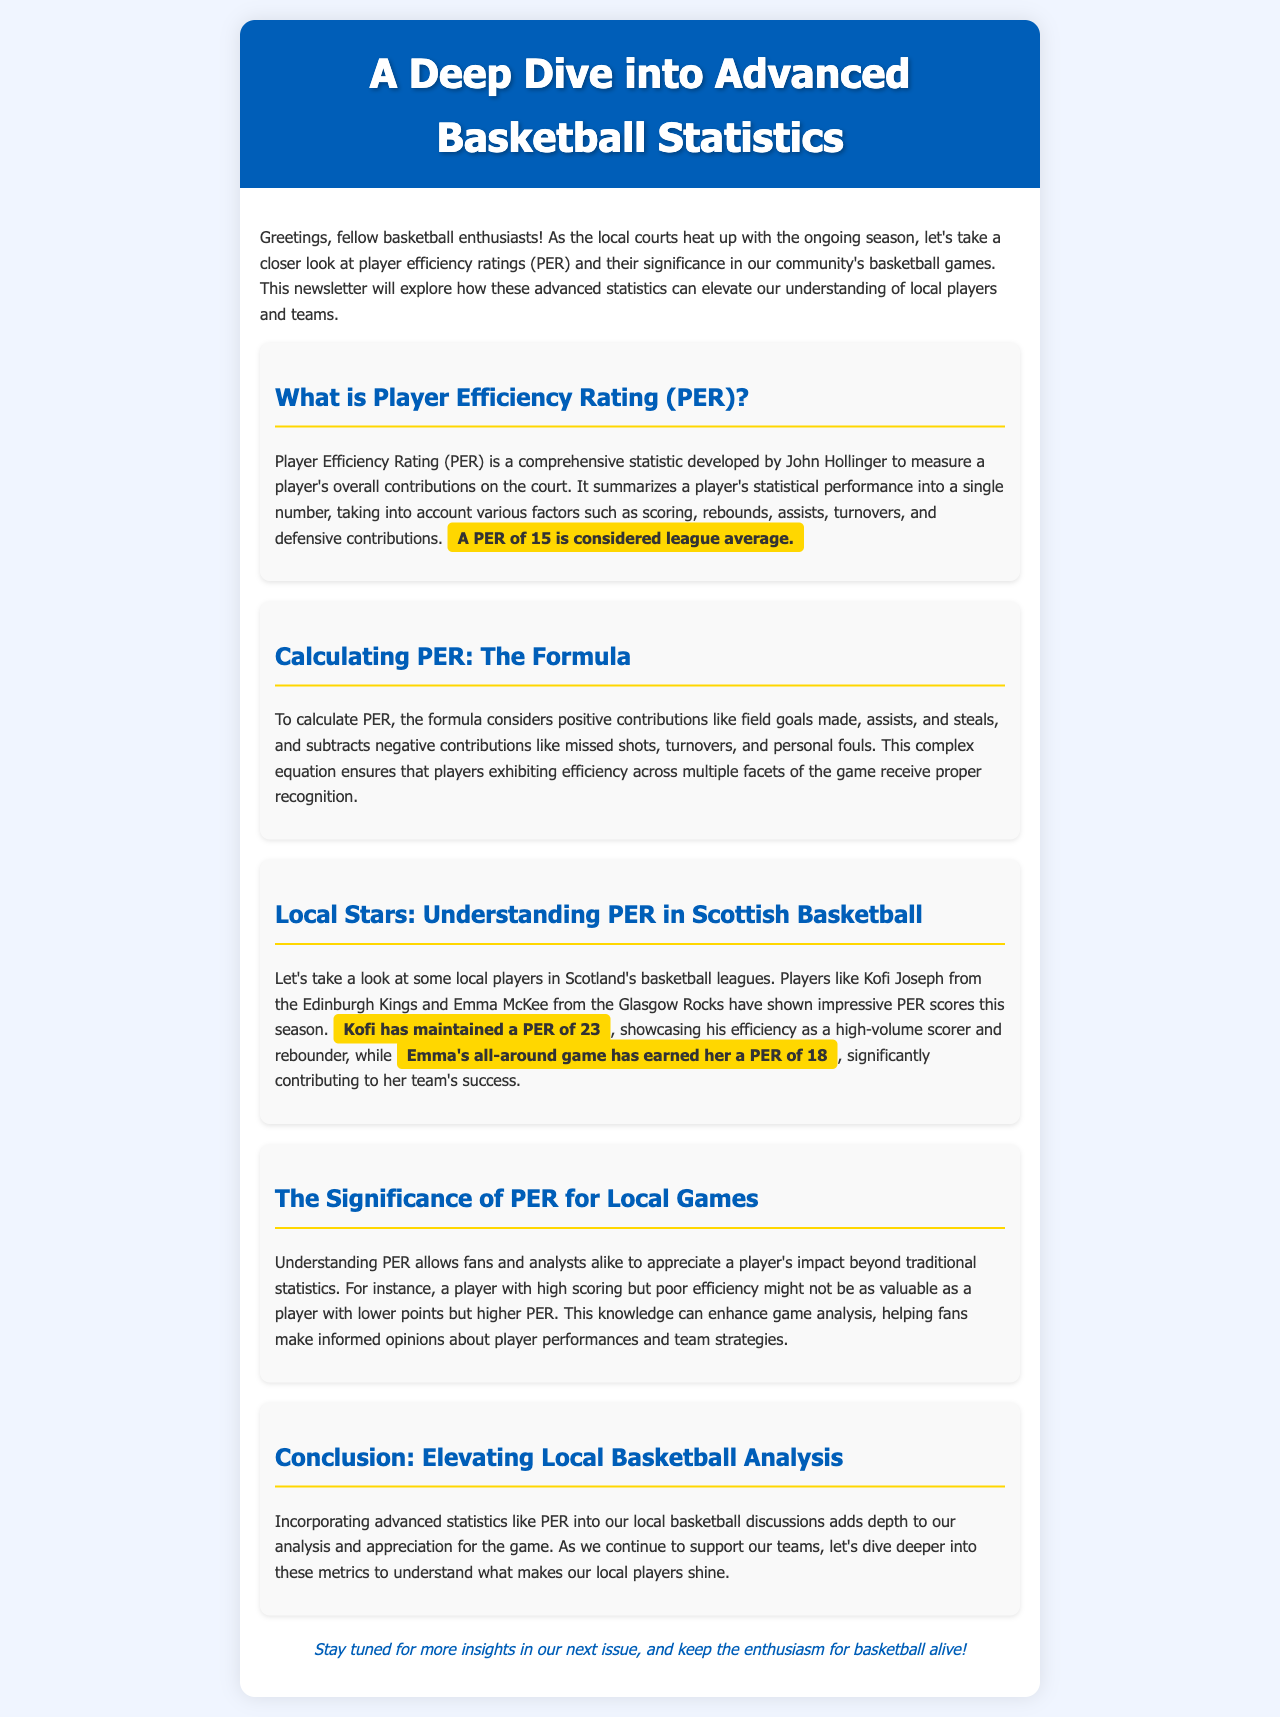What does PER stand for? The document defines the acronym PER in the context of basketball statistics.
Answer: Player Efficiency Rating Who developed the Player Efficiency Rating? The document states who developed the statistic.
Answer: John Hollinger What is the league average PER score? The document specifies what is considered the league average PER score.
Answer: 15 What is Kofi Joseph's PER score? The document reports Kofi Joseph's PER score.
Answer: 23 What is Emma McKee's PER score? The document provides Emma McKee's PER score for this season.
Answer: 18 Why is understanding PER important for fans? The document explains why it’s beneficial for fans to understand PER.
Answer: It helps appreciate a player's impact beyond traditional statistics What does a high scoring but poor efficiency player indicate? The document discusses implications of scoring and efficiency ratings.
Answer: They might not be as valuable What is the primary focus of this newsletter? The document summarizes the main topic covered in the newsletter.
Answer: Advanced basketball statistics 